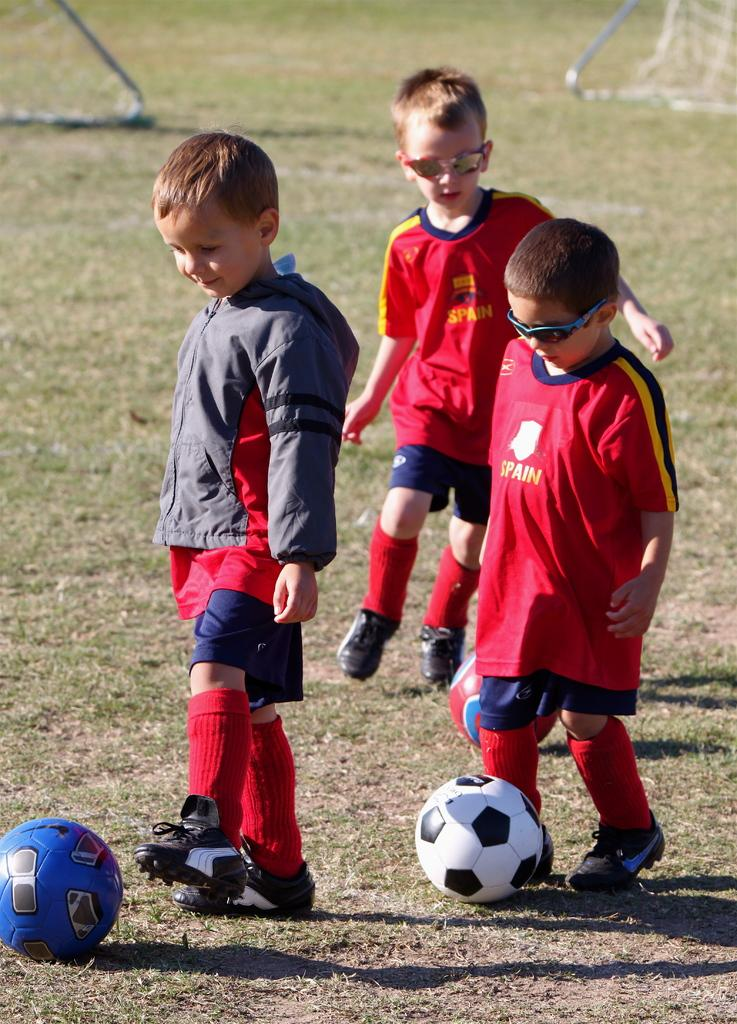How many boys are present in the image? There are three boys in the image. What activity are the boys engaged in? The boys are playing football. Can you describe the facial expression of one of the boys? One of the boys is smiling. What type of surface is visible in the image? There is grass in the image. What grade level is the football game being played at in the image? There is no indication of a grade level or any educational context in the image; it simply shows three boys playing football on grass. Can you tell me how many times the boys have folded the football in the image? There is no mention of folding the football in the image; the boys are playing with an inflated football. 